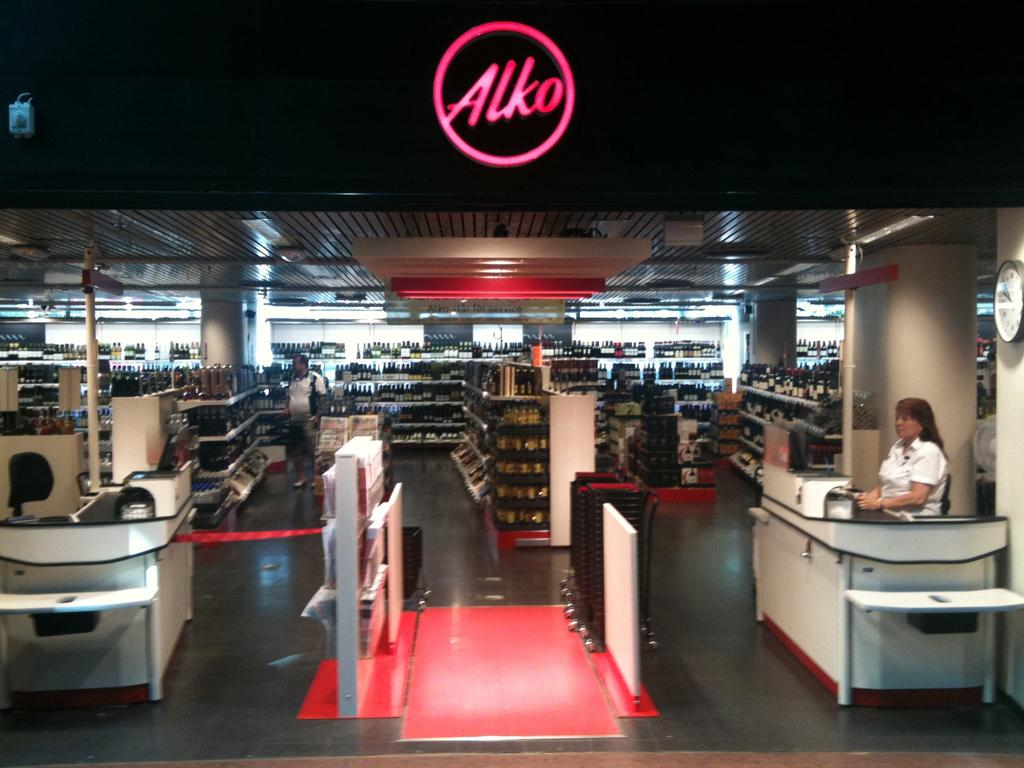<image>
Render a clear and concise summary of the photo. Woman waiting for customers in an Alko store. 